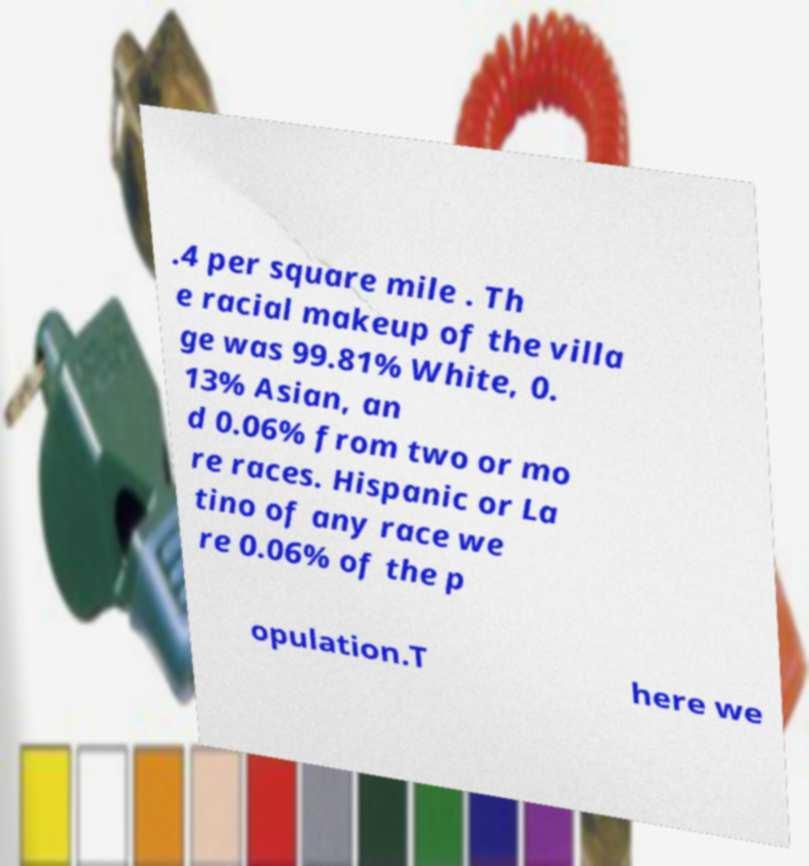What messages or text are displayed in this image? I need them in a readable, typed format. .4 per square mile . Th e racial makeup of the villa ge was 99.81% White, 0. 13% Asian, an d 0.06% from two or mo re races. Hispanic or La tino of any race we re 0.06% of the p opulation.T here we 